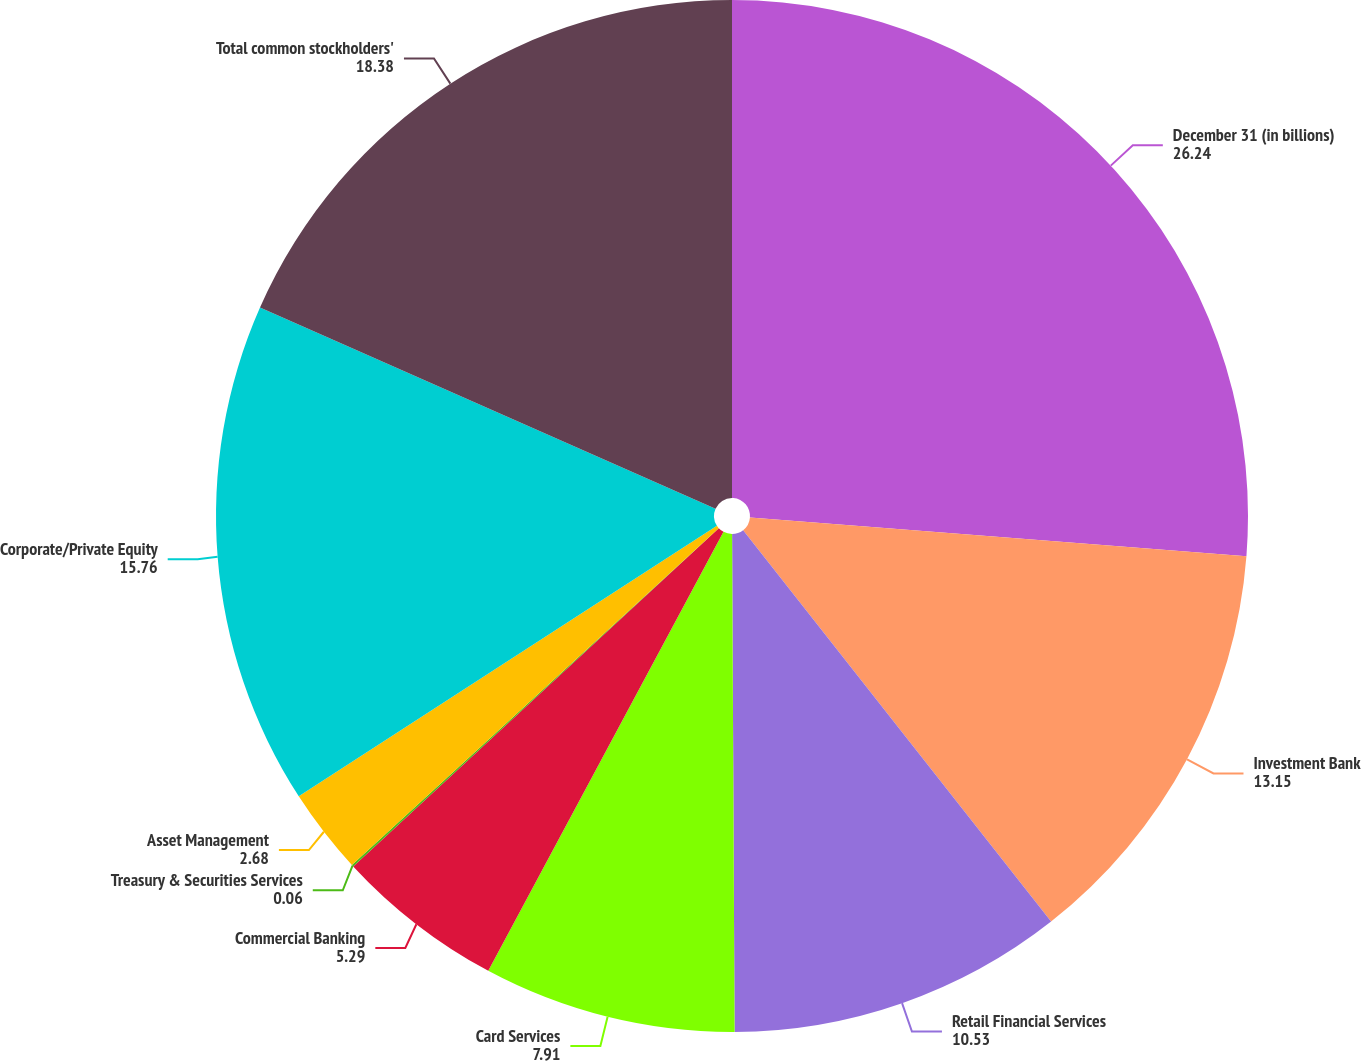<chart> <loc_0><loc_0><loc_500><loc_500><pie_chart><fcel>December 31 (in billions)<fcel>Investment Bank<fcel>Retail Financial Services<fcel>Card Services<fcel>Commercial Banking<fcel>Treasury & Securities Services<fcel>Asset Management<fcel>Corporate/Private Equity<fcel>Total common stockholders'<nl><fcel>26.24%<fcel>13.15%<fcel>10.53%<fcel>7.91%<fcel>5.29%<fcel>0.06%<fcel>2.68%<fcel>15.76%<fcel>18.38%<nl></chart> 